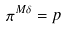Convert formula to latex. <formula><loc_0><loc_0><loc_500><loc_500>\pi ^ { M \delta } = p</formula> 